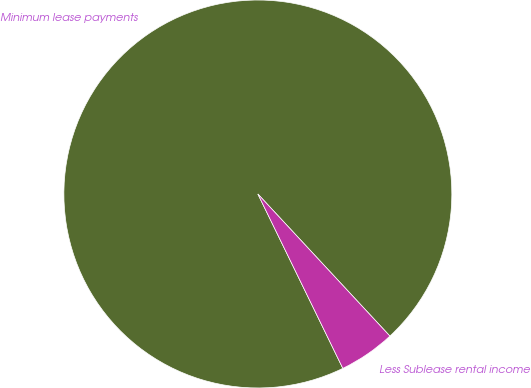Convert chart to OTSL. <chart><loc_0><loc_0><loc_500><loc_500><pie_chart><fcel>Minimum lease payments<fcel>Less Sublease rental income<nl><fcel>95.3%<fcel>4.7%<nl></chart> 